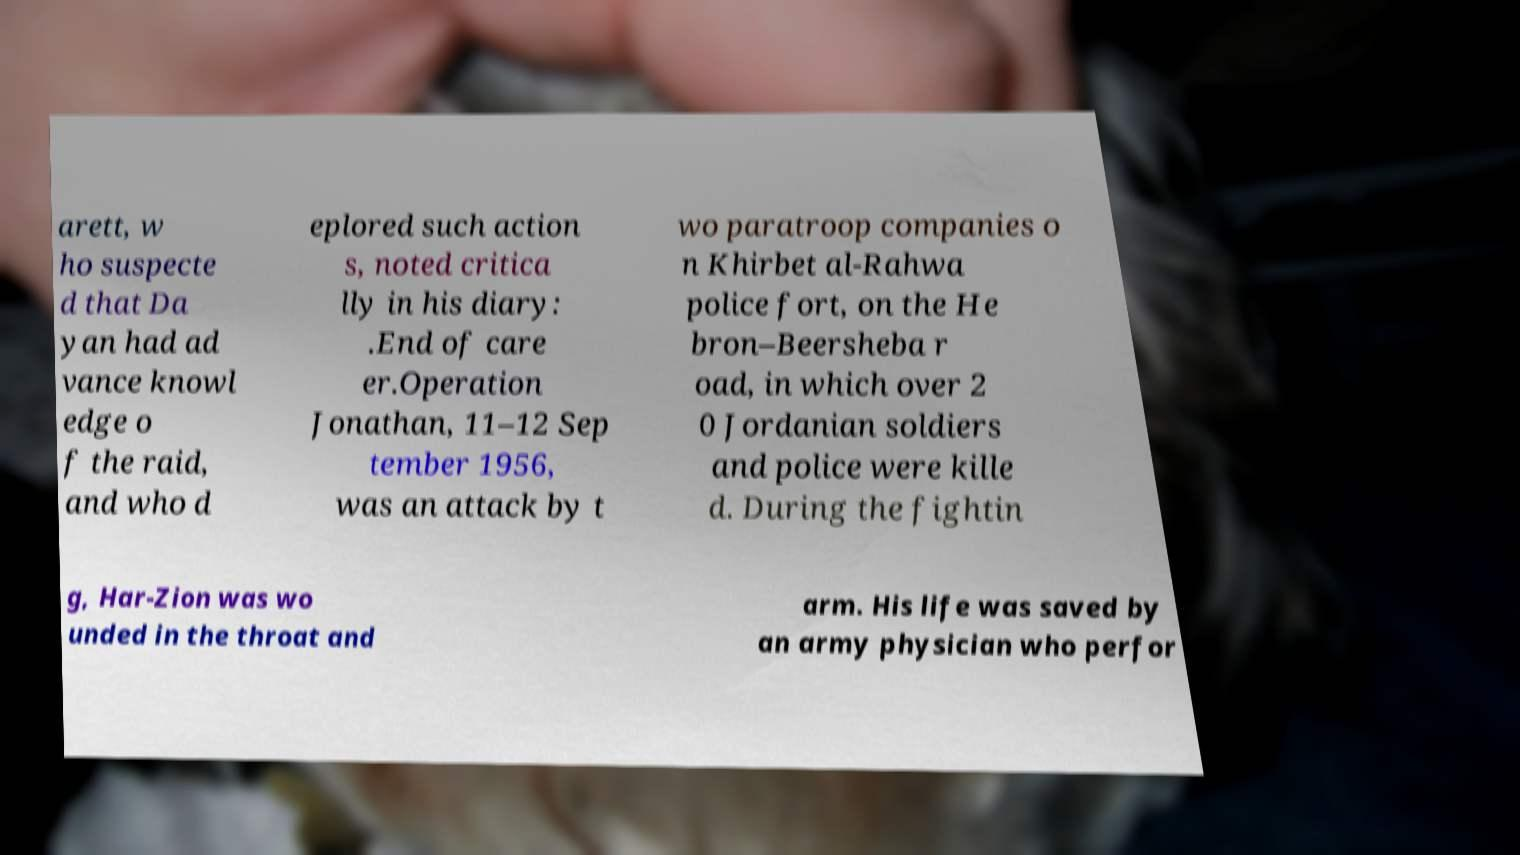Could you extract and type out the text from this image? arett, w ho suspecte d that Da yan had ad vance knowl edge o f the raid, and who d eplored such action s, noted critica lly in his diary: .End of care er.Operation Jonathan, 11–12 Sep tember 1956, was an attack by t wo paratroop companies o n Khirbet al-Rahwa police fort, on the He bron–Beersheba r oad, in which over 2 0 Jordanian soldiers and police were kille d. During the fightin g, Har-Zion was wo unded in the throat and arm. His life was saved by an army physician who perfor 